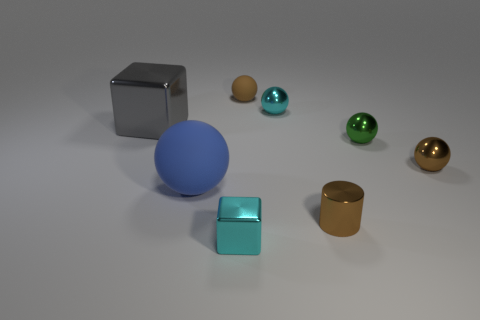Can you describe the sizes and arrangement of the objects in front of the large gray thing? Certainly! In front of the gray object, there appears to be a collection of geometric shapes arranged from largest to smallest from left to right. Starting with a sizable blue sphere, followed by a medium-sized cyan cube, then progressively smaller spheres in gold, green, and bronze.  Besides color, how does the texture of these objects differ? Textures vary widely among these objects. The blue sphere and cyan cube have a smooth, matte finish, while the smaller spheres have a polished, reflective surface that gives them a shiny appearance, catching and mirroring the light from their surroundings. 